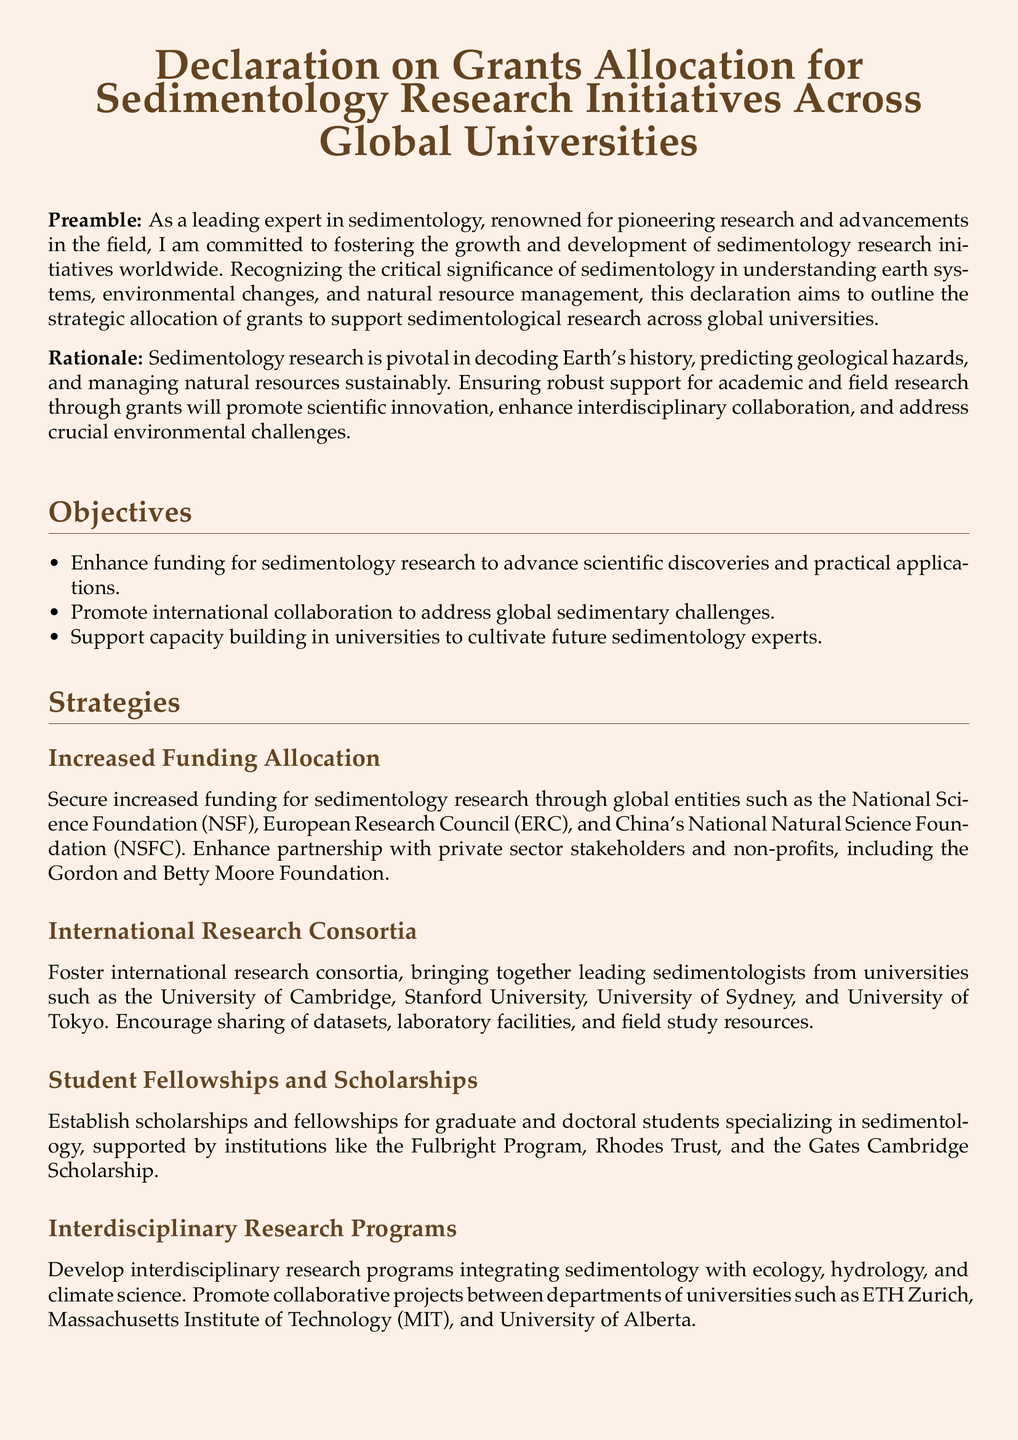What is the main focus of the declaration? The main focus of the declaration is to outline the strategic allocation of grants to support sedimentological research across global universities.
Answer: strategic allocation of grants to support sedimentological research across global universities Which organizations are mentioned for increased funding? The document mentions global entities such as the National Science Foundation, European Research Council, and China's National Natural Science Foundation for increased funding.
Answer: National Science Foundation, European Research Council, National Natural Science Foundation What is one of the objectives stated in the document? One of the objectives is to enhance funding for sedimentology research to advance scientific discoveries and practical applications.
Answer: enhance funding for sedimentology research What type of programs are being developed according to the strategies? The strategies discuss developing interdisciplinary research programs integrating sedimentology with ecology, hydrology, and climate science.
Answer: interdisciplinary research programs Who is responsible for organizing the annual conferences? The annual international conferences and workshops are sponsored by organizations such as the International Association of Sedimentologists and the Geological Society of America.
Answer: International Association of Sedimentologists, Geological Society of America What is one way to support future sedimentology experts? The document suggests establishing scholarships and fellowships for graduate and doctoral students specializing in sedimentology.
Answer: establishing scholarships and fellowships What is the overarching goal of the declaration? The overarching goal of the declaration is to advance sedimentological science for the benefit of society and the natural world.
Answer: advance sedimentological science for the benefit of society and the natural world Which document type does this declaration represent? This declaration represents a formal statement aimed at outlining strategic plans and objectives.
Answer: formal statement 